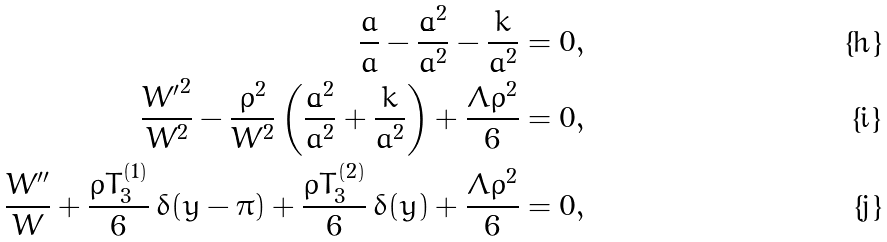Convert formula to latex. <formula><loc_0><loc_0><loc_500><loc_500>\frac { \ddot { a } } { a } - \frac { \dot { a } ^ { 2 } } { a ^ { 2 } } - \frac { k } { a ^ { 2 } } = 0 , \\ \frac { { W ^ { \prime } } ^ { 2 } } { W ^ { 2 } } - \frac { \rho ^ { 2 } } { W ^ { 2 } } \left ( \frac { \dot { a } ^ { 2 } } { a ^ { 2 } } + \frac { k } { a ^ { 2 } } \right ) + \frac { \Lambda \rho ^ { 2 } } { 6 } = 0 , \\ \frac { W ^ { \prime \prime } } { W } + \frac { \rho T _ { 3 } ^ { ( 1 ) } } { 6 } \, \delta ( y - \pi ) + \frac { \rho T _ { 3 } ^ { ( 2 ) } } { 6 } \, \delta ( y ) + \frac { \Lambda \rho ^ { 2 } } { 6 } = 0 ,</formula> 